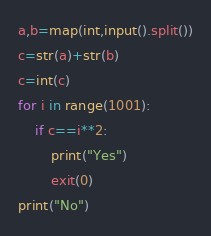Convert code to text. <code><loc_0><loc_0><loc_500><loc_500><_Python_>a,b=map(int,input().split())
c=str(a)+str(b)
c=int(c)
for i in range(1001):
    if c==i**2:
        print("Yes")
        exit(0)
print("No")</code> 